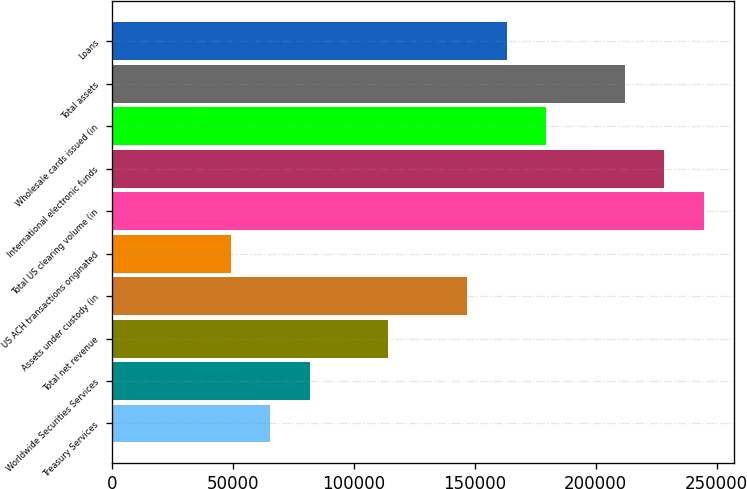Convert chart. <chart><loc_0><loc_0><loc_500><loc_500><bar_chart><fcel>Treasury Services<fcel>Worldwide Securities Services<fcel>Total net revenue<fcel>Assets under custody (in<fcel>US ACH transactions originated<fcel>Total US clearing volume (in<fcel>International electronic funds<fcel>Wholesale cards issued (in<fcel>Total assets<fcel>Loans<nl><fcel>65306.6<fcel>81617<fcel>114238<fcel>146859<fcel>48996.2<fcel>244721<fcel>228411<fcel>179479<fcel>212100<fcel>163169<nl></chart> 